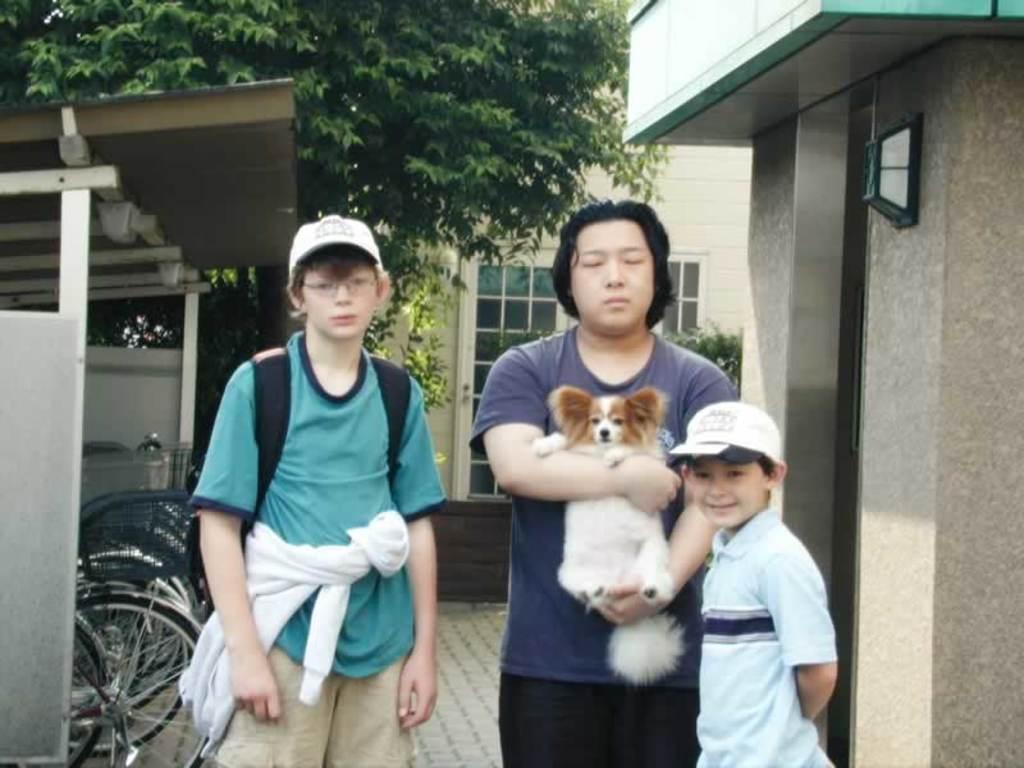What type of natural elements can be seen in the image? There are trees in the image. What type of man-made structure is present in the image? There is a building in the image. How many people are visible in the image? There are three people standing in the image. What mode of transportation can be seen in the image? There are bicycles in the image. How many dust particles can be seen on the bicycles in the image? There is no mention of dust particles in the image, so it is impossible to determine their quantity. Where did the people in the image go on vacation? There is no information about a vacation in the image, so it cannot be determined where the people went. 